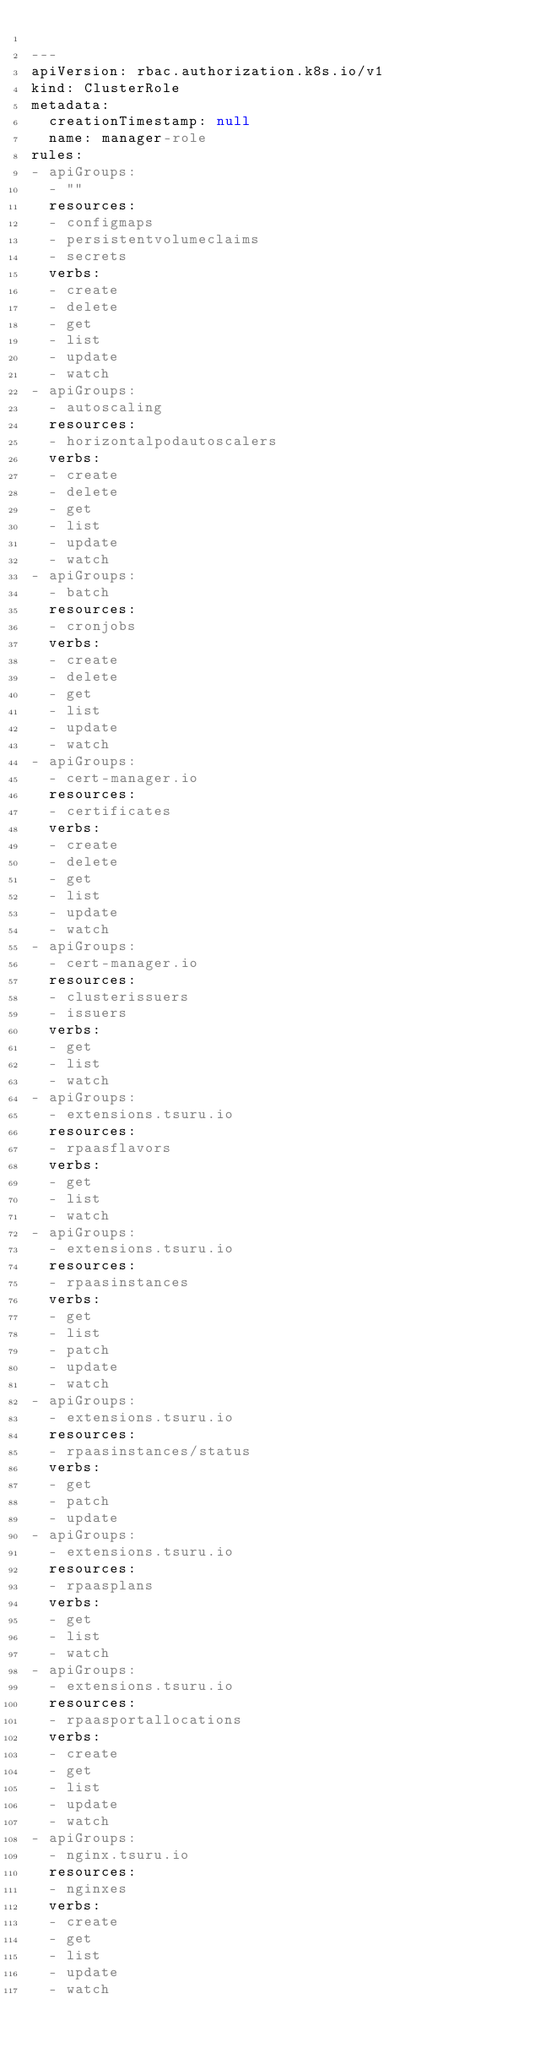Convert code to text. <code><loc_0><loc_0><loc_500><loc_500><_YAML_>
---
apiVersion: rbac.authorization.k8s.io/v1
kind: ClusterRole
metadata:
  creationTimestamp: null
  name: manager-role
rules:
- apiGroups:
  - ""
  resources:
  - configmaps
  - persistentvolumeclaims
  - secrets
  verbs:
  - create
  - delete
  - get
  - list
  - update
  - watch
- apiGroups:
  - autoscaling
  resources:
  - horizontalpodautoscalers
  verbs:
  - create
  - delete
  - get
  - list
  - update
  - watch
- apiGroups:
  - batch
  resources:
  - cronjobs
  verbs:
  - create
  - delete
  - get
  - list
  - update
  - watch
- apiGroups:
  - cert-manager.io
  resources:
  - certificates
  verbs:
  - create
  - delete
  - get
  - list
  - update
  - watch
- apiGroups:
  - cert-manager.io
  resources:
  - clusterissuers
  - issuers
  verbs:
  - get
  - list
  - watch
- apiGroups:
  - extensions.tsuru.io
  resources:
  - rpaasflavors
  verbs:
  - get
  - list
  - watch
- apiGroups:
  - extensions.tsuru.io
  resources:
  - rpaasinstances
  verbs:
  - get
  - list
  - patch
  - update
  - watch
- apiGroups:
  - extensions.tsuru.io
  resources:
  - rpaasinstances/status
  verbs:
  - get
  - patch
  - update
- apiGroups:
  - extensions.tsuru.io
  resources:
  - rpaasplans
  verbs:
  - get
  - list
  - watch
- apiGroups:
  - extensions.tsuru.io
  resources:
  - rpaasportallocations
  verbs:
  - create
  - get
  - list
  - update
  - watch
- apiGroups:
  - nginx.tsuru.io
  resources:
  - nginxes
  verbs:
  - create
  - get
  - list
  - update
  - watch
</code> 